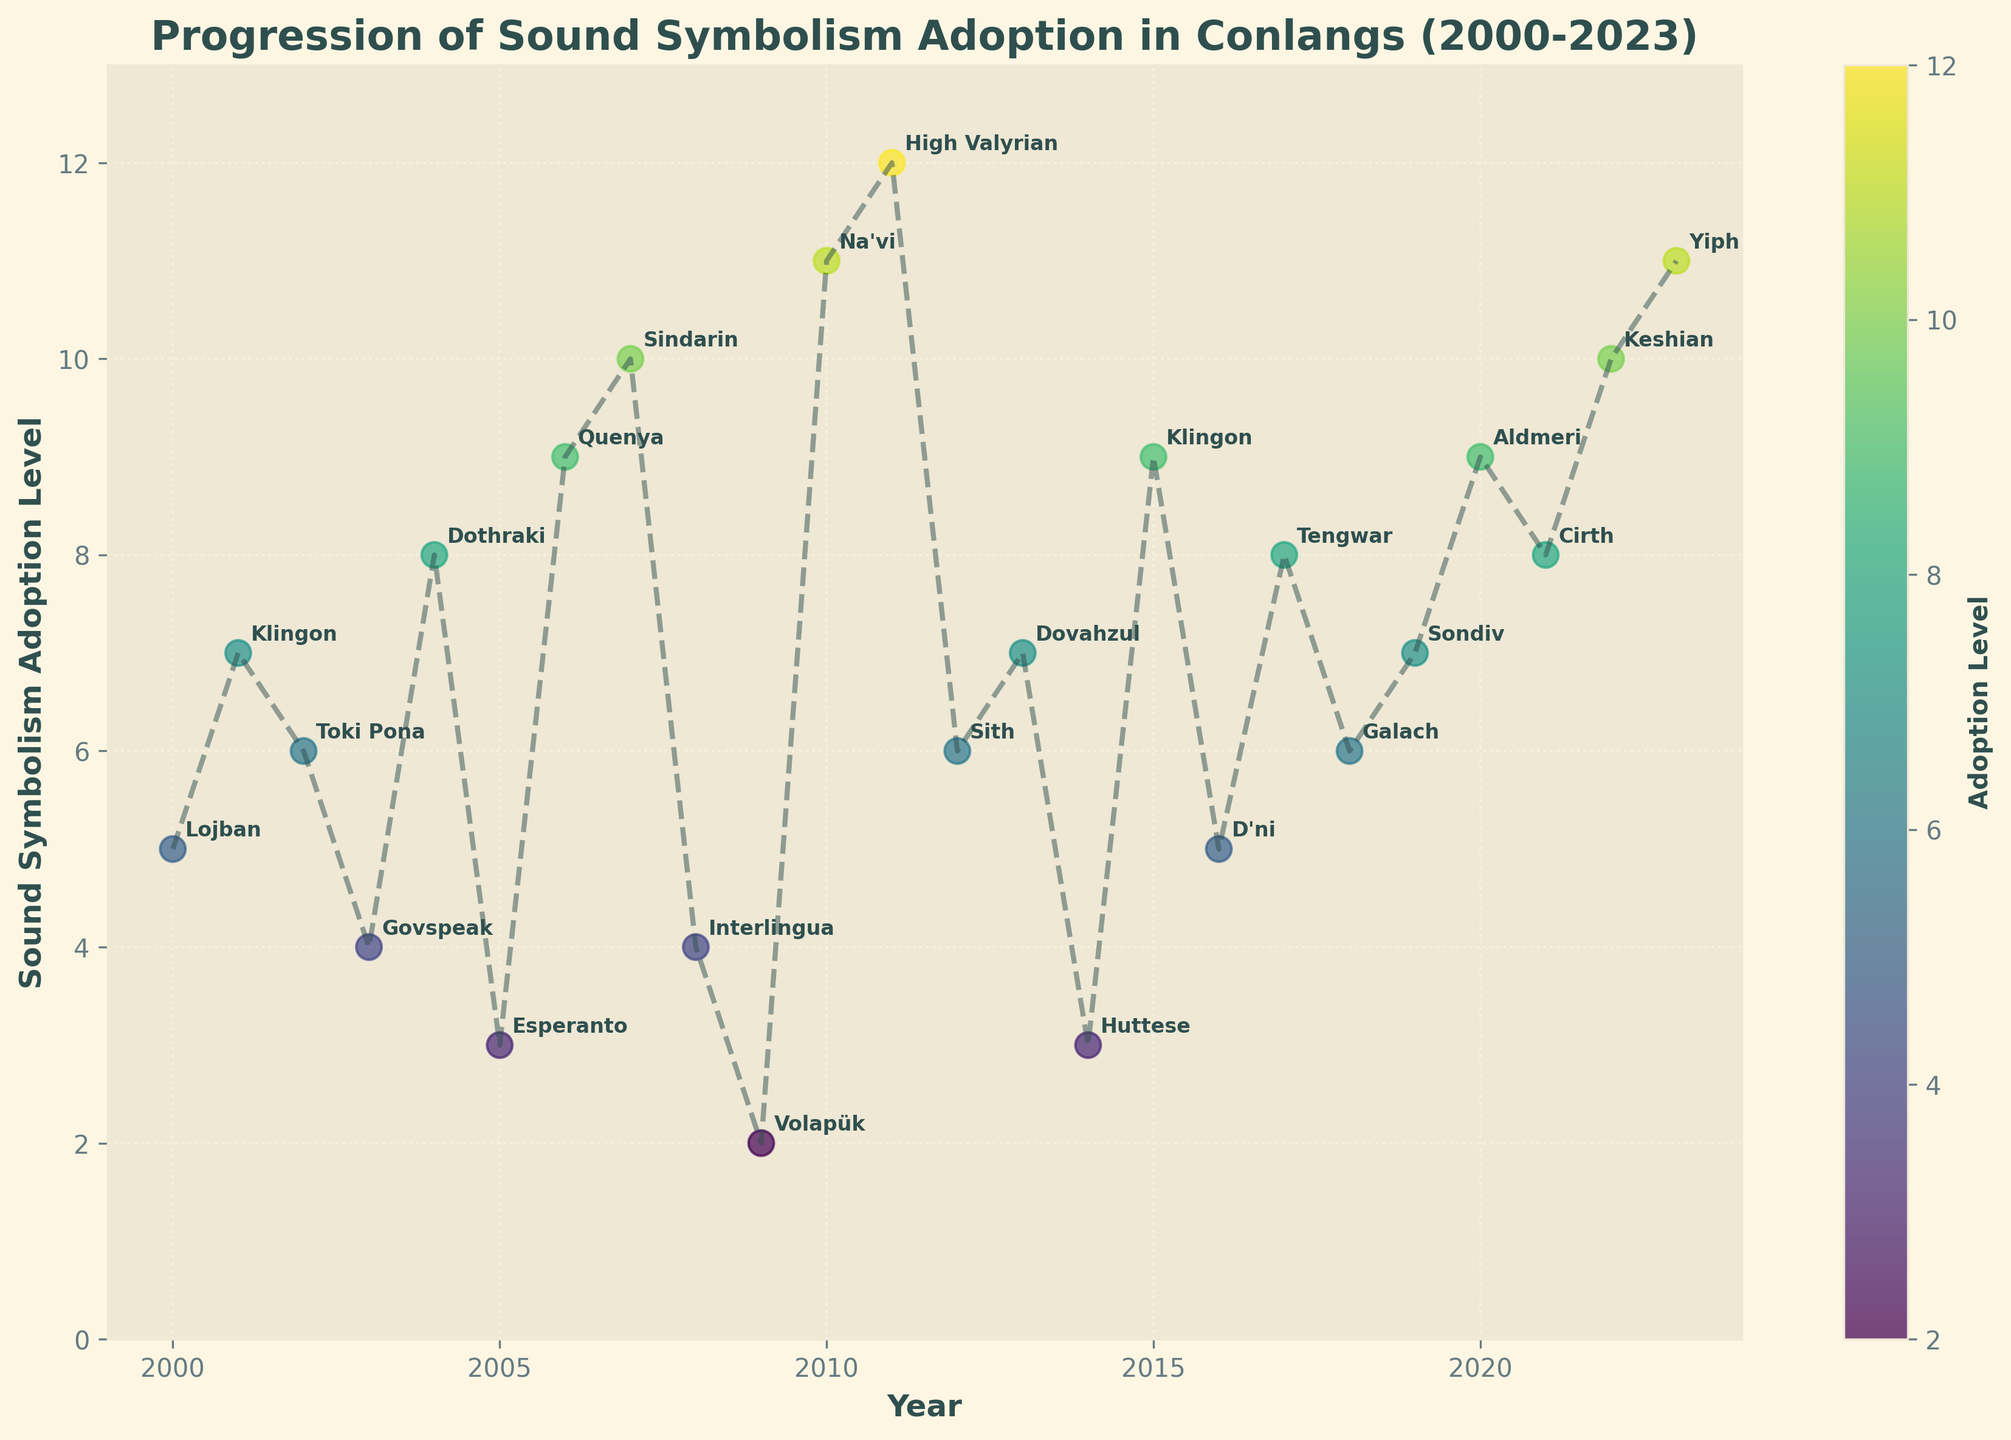What's the title of the figure? The title of the figure is the large text at the top of the plot that describes the overall content. In this case, it is: "Progression of Sound Symbolism Adoption in Conlangs (2000-2023)"
Answer: Progression of Sound Symbolism Adoption in Conlangs (2000-2023) What are the labels for the x-axis and y-axis? The x-axis label, located below the horizontal axis, is "Year". The y-axis label, located beside the vertical axis, is "Sound Symbolism Adoption Level".
Answer: Year, Sound Symbolism Adoption Level How many data points are there between 2000 and 2023, inclusive? To find the number of data points, count all the labeled points (represented by the conlangs) from the earliest year (2000) to the latest year (2023) on the plot. There are 24 data points in total.
Answer: 24 Which year has the highest level of sound symbolism adoption? To identify the year with the highest value, look for the highest point on the vertical axis that corresponds to the highest level of sound symbolism adoption. In this figure, it is 2011, with a level of 12.
Answer: 2011 What is the median sound symbolism adoption level from 2000 to 2023? To find the median, first sort the adoption levels from 2000 to 2023: [2, 3, 3, 4, 4, 5, 5, 6, 6, 6, 7, 7, 7, 8, 8, 8, 9, 9, 9, 10, 10, 11, 11, 12]. The median value, which is the middle value of this ordered list, is the average of the 12th and 13th values. Therefore, (7+7)/2 = 7.
Answer: 7 Which conlang has the lowest adoption level and in which year? To answer this, find the lowest point on the y-axis and check the corresponding conlang and year. The lowest adoption level is for Volapük in 2009, with a level of 2.
Answer: Volapük, 2009 How many conlangs have an adoption level of 10 or above? Count the number of data points that have an adoption level of 10 or above by looking at the vertical axis labels. There are 5 such points (2011, 2017, 2022, 2023, Na'vi in 2010).
Answer: 5 Is there a general trend in the adoption level from 2000 to 2023? Observe the general direction of the points in the plot: if the overall trend is rising, falling, or steady. Here, there's an overall upward trend in the adoption level moving from 2000 (5 for Lojban) to 2023 (11 for Yiph).
Answer: Upward trend In which years did Klingon appear, and what were its adoption levels in those years? Identify the years where Klingon appears and check the corresponding adoption levels. Klingon appears in 2001 with an adoption level of 7 and in 2015 with an adoption level of 9.
Answer: 2001 (7), 2015 (9) Which conlang shows the most significant increase in adoption level over consecutive years? By examining the data points, find the conlang with the most significant increase between two consecutive years. High Valyrian shows the most significant increase, going from an adoption level of 6 in 2012 (Sith) to 12 in 2011.
Answer: High Valyrian 